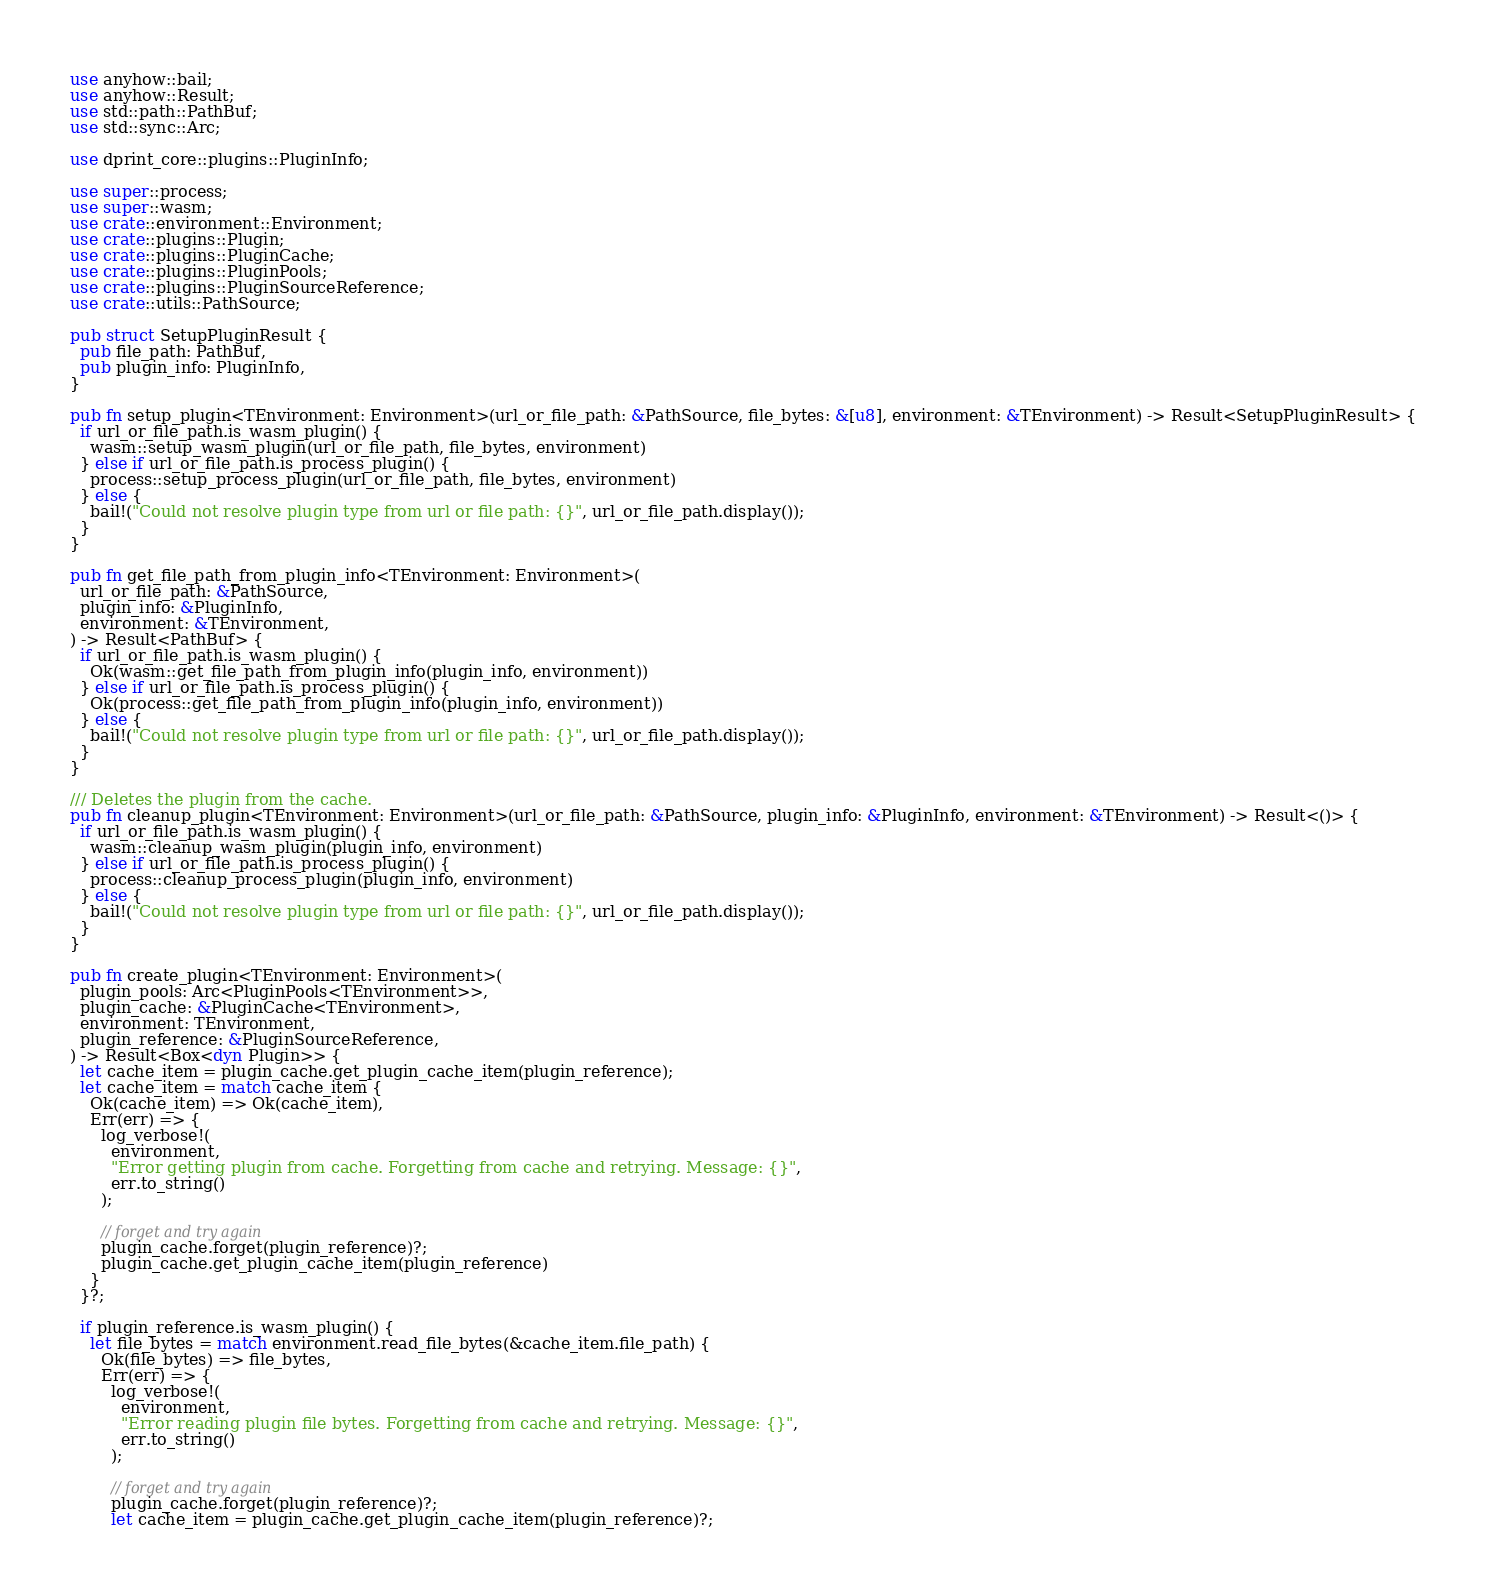<code> <loc_0><loc_0><loc_500><loc_500><_Rust_>use anyhow::bail;
use anyhow::Result;
use std::path::PathBuf;
use std::sync::Arc;

use dprint_core::plugins::PluginInfo;

use super::process;
use super::wasm;
use crate::environment::Environment;
use crate::plugins::Plugin;
use crate::plugins::PluginCache;
use crate::plugins::PluginPools;
use crate::plugins::PluginSourceReference;
use crate::utils::PathSource;

pub struct SetupPluginResult {
  pub file_path: PathBuf,
  pub plugin_info: PluginInfo,
}

pub fn setup_plugin<TEnvironment: Environment>(url_or_file_path: &PathSource, file_bytes: &[u8], environment: &TEnvironment) -> Result<SetupPluginResult> {
  if url_or_file_path.is_wasm_plugin() {
    wasm::setup_wasm_plugin(url_or_file_path, file_bytes, environment)
  } else if url_or_file_path.is_process_plugin() {
    process::setup_process_plugin(url_or_file_path, file_bytes, environment)
  } else {
    bail!("Could not resolve plugin type from url or file path: {}", url_or_file_path.display());
  }
}

pub fn get_file_path_from_plugin_info<TEnvironment: Environment>(
  url_or_file_path: &PathSource,
  plugin_info: &PluginInfo,
  environment: &TEnvironment,
) -> Result<PathBuf> {
  if url_or_file_path.is_wasm_plugin() {
    Ok(wasm::get_file_path_from_plugin_info(plugin_info, environment))
  } else if url_or_file_path.is_process_plugin() {
    Ok(process::get_file_path_from_plugin_info(plugin_info, environment))
  } else {
    bail!("Could not resolve plugin type from url or file path: {}", url_or_file_path.display());
  }
}

/// Deletes the plugin from the cache.
pub fn cleanup_plugin<TEnvironment: Environment>(url_or_file_path: &PathSource, plugin_info: &PluginInfo, environment: &TEnvironment) -> Result<()> {
  if url_or_file_path.is_wasm_plugin() {
    wasm::cleanup_wasm_plugin(plugin_info, environment)
  } else if url_or_file_path.is_process_plugin() {
    process::cleanup_process_plugin(plugin_info, environment)
  } else {
    bail!("Could not resolve plugin type from url or file path: {}", url_or_file_path.display());
  }
}

pub fn create_plugin<TEnvironment: Environment>(
  plugin_pools: Arc<PluginPools<TEnvironment>>,
  plugin_cache: &PluginCache<TEnvironment>,
  environment: TEnvironment,
  plugin_reference: &PluginSourceReference,
) -> Result<Box<dyn Plugin>> {
  let cache_item = plugin_cache.get_plugin_cache_item(plugin_reference);
  let cache_item = match cache_item {
    Ok(cache_item) => Ok(cache_item),
    Err(err) => {
      log_verbose!(
        environment,
        "Error getting plugin from cache. Forgetting from cache and retrying. Message: {}",
        err.to_string()
      );

      // forget and try again
      plugin_cache.forget(plugin_reference)?;
      plugin_cache.get_plugin_cache_item(plugin_reference)
    }
  }?;

  if plugin_reference.is_wasm_plugin() {
    let file_bytes = match environment.read_file_bytes(&cache_item.file_path) {
      Ok(file_bytes) => file_bytes,
      Err(err) => {
        log_verbose!(
          environment,
          "Error reading plugin file bytes. Forgetting from cache and retrying. Message: {}",
          err.to_string()
        );

        // forget and try again
        plugin_cache.forget(plugin_reference)?;
        let cache_item = plugin_cache.get_plugin_cache_item(plugin_reference)?;</code> 